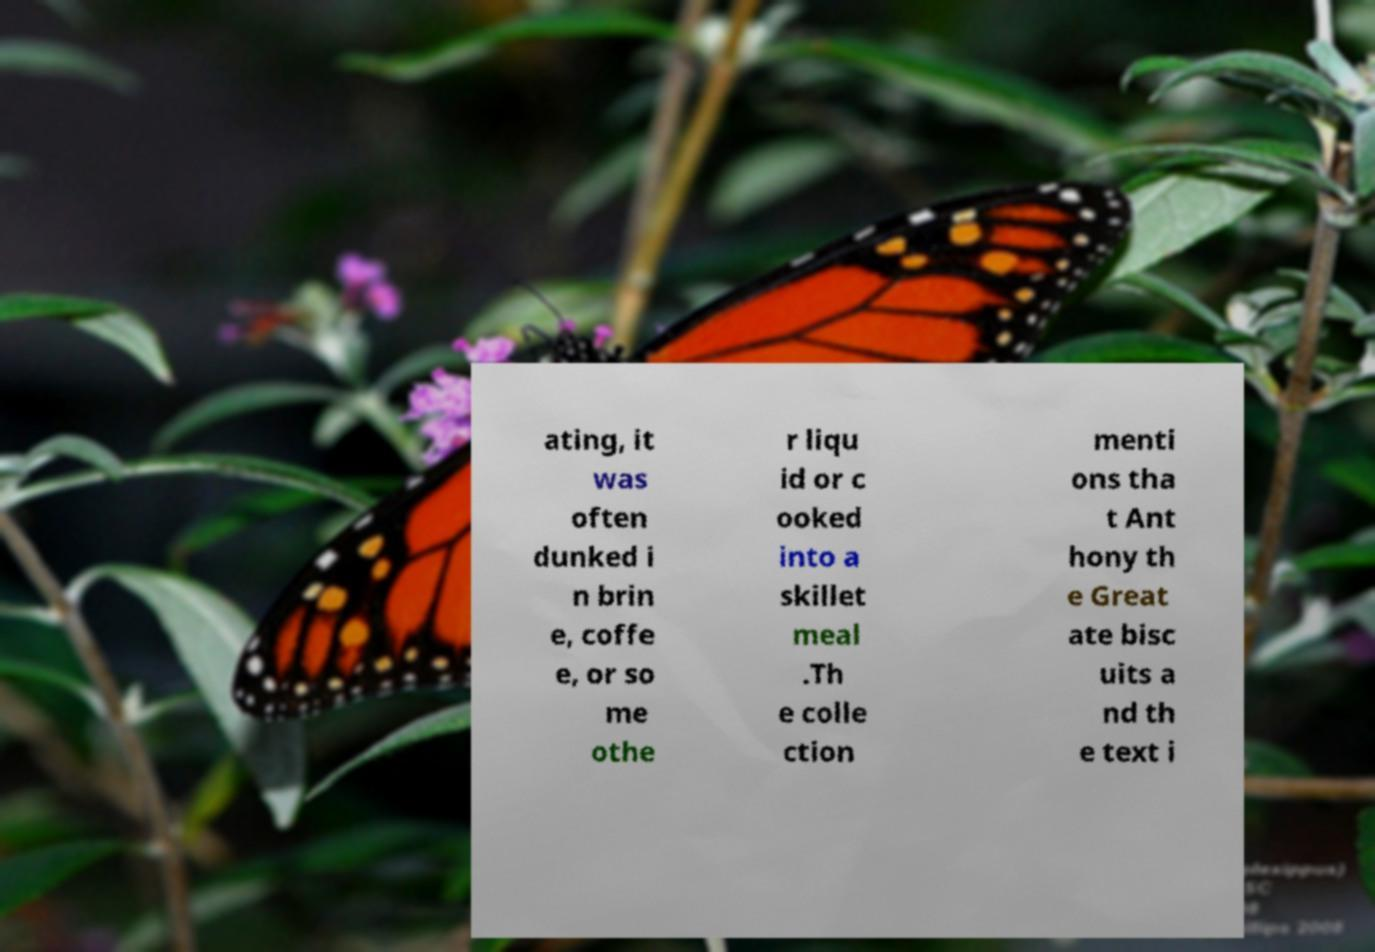There's text embedded in this image that I need extracted. Can you transcribe it verbatim? ating, it was often dunked i n brin e, coffe e, or so me othe r liqu id or c ooked into a skillet meal .Th e colle ction menti ons tha t Ant hony th e Great ate bisc uits a nd th e text i 